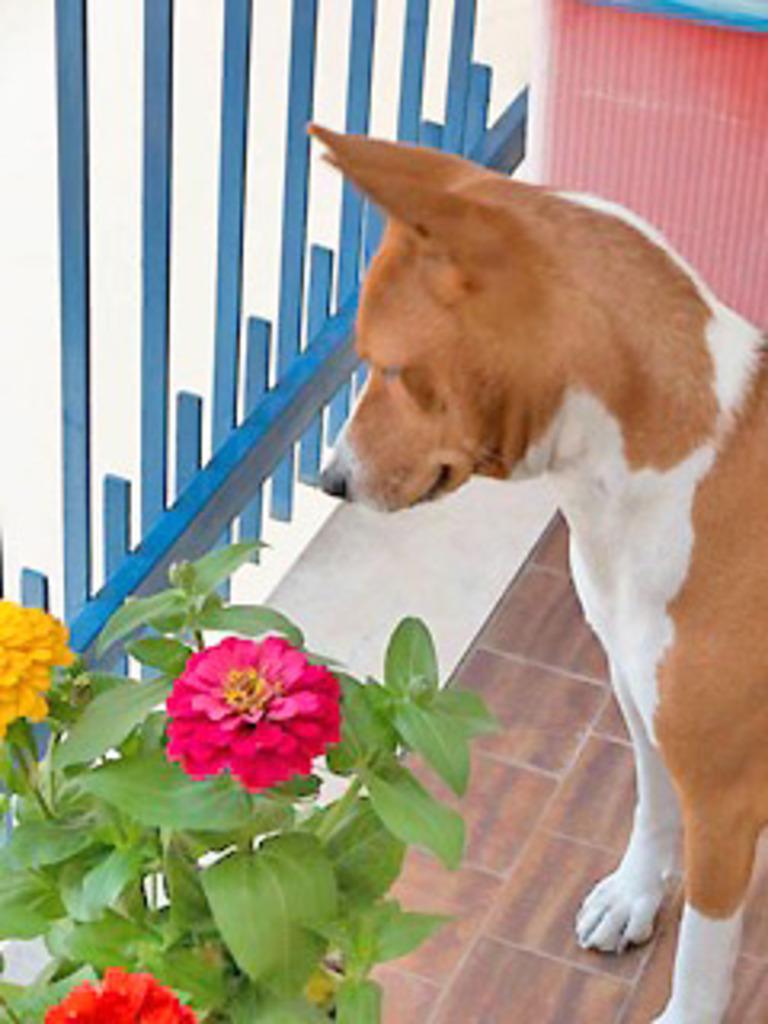Can you describe this image briefly? In this image, we can see a dog is standing on the floor. On the left side bottom corner, we can see flower plant. Background we can see wall and grill. 